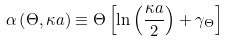<formula> <loc_0><loc_0><loc_500><loc_500>\alpha \left ( \Theta , \kappa a \right ) \equiv \Theta \left [ \ln \left ( \frac { \kappa a } { 2 } \right ) + \gamma _ { \Theta } \right ] \,</formula> 